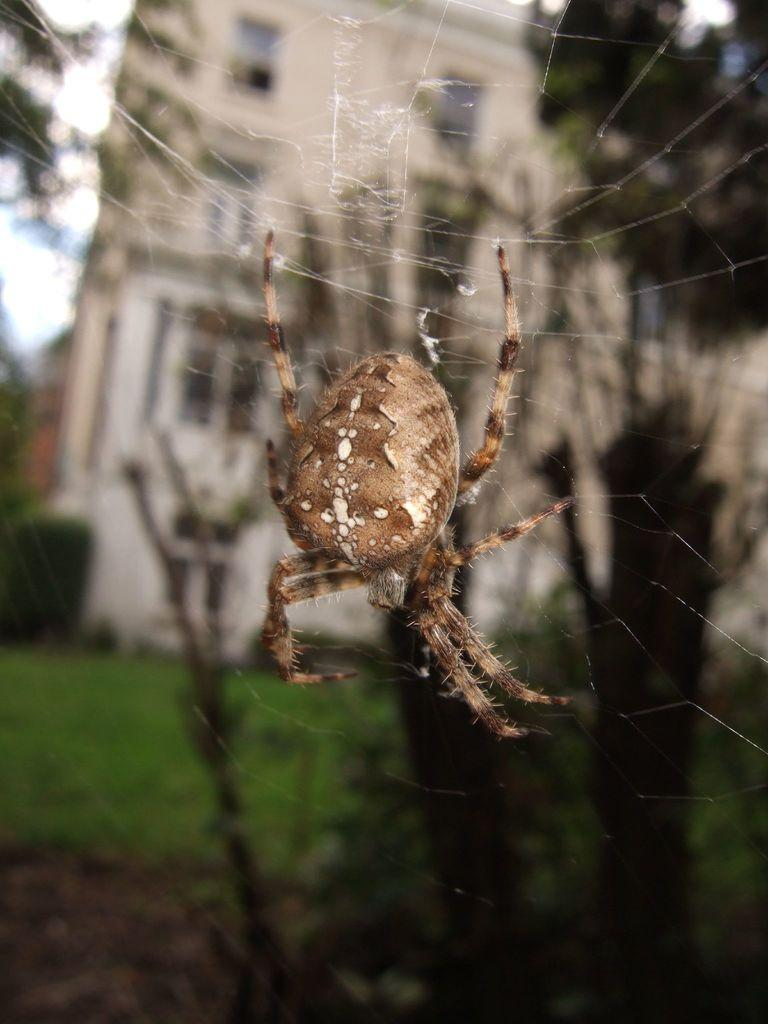What is the main subject of the image? There is a spider in the image. Where is the spider located? The spider is on a spider web. What can be seen in the background of the image? There are plants and trees, as well as a building, in the background of the image. What type of humor can be seen in the image? There is no humor present in the image; it features a spider on a spider web with a background of plants, trees, and a building. 